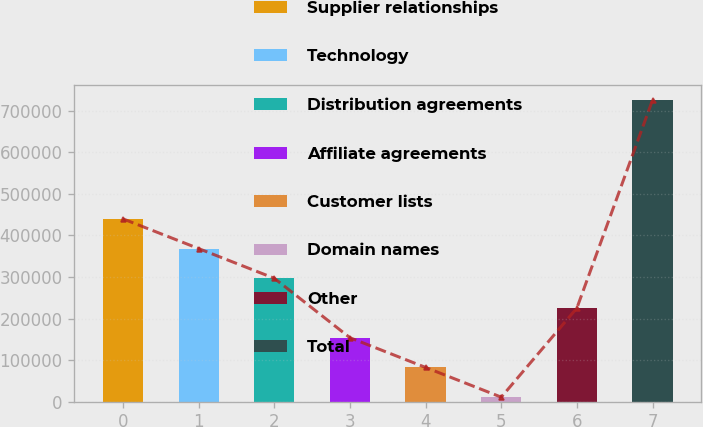Convert chart. <chart><loc_0><loc_0><loc_500><loc_500><bar_chart><fcel>Supplier relationships<fcel>Technology<fcel>Distribution agreements<fcel>Affiliate agreements<fcel>Customer lists<fcel>Domain names<fcel>Other<fcel>Total<nl><fcel>439565<fcel>368128<fcel>296690<fcel>153815<fcel>82377.5<fcel>10940<fcel>225252<fcel>725315<nl></chart> 